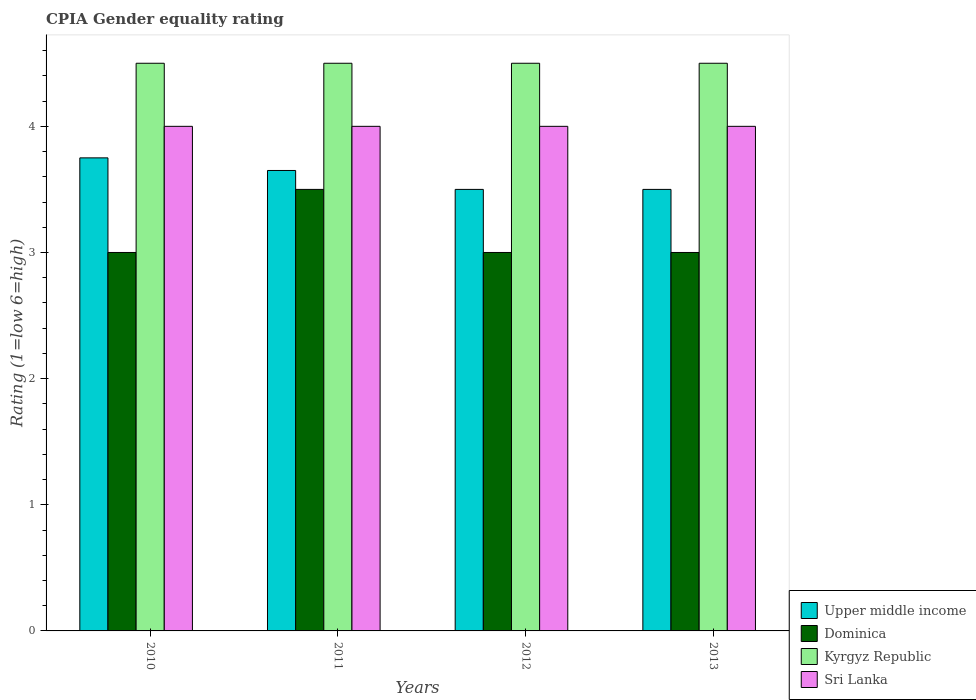How many different coloured bars are there?
Your response must be concise. 4. Are the number of bars per tick equal to the number of legend labels?
Offer a very short reply. Yes. How many bars are there on the 4th tick from the left?
Make the answer very short. 4. In how many cases, is the number of bars for a given year not equal to the number of legend labels?
Make the answer very short. 0. What is the CPIA rating in Upper middle income in 2013?
Provide a short and direct response. 3.5. Across all years, what is the maximum CPIA rating in Upper middle income?
Keep it short and to the point. 3.75. In which year was the CPIA rating in Kyrgyz Republic maximum?
Keep it short and to the point. 2010. What is the total CPIA rating in Sri Lanka in the graph?
Give a very brief answer. 16. Is the difference between the CPIA rating in Sri Lanka in 2010 and 2012 greater than the difference between the CPIA rating in Kyrgyz Republic in 2010 and 2012?
Your answer should be compact. No. In how many years, is the CPIA rating in Dominica greater than the average CPIA rating in Dominica taken over all years?
Your response must be concise. 1. What does the 4th bar from the left in 2012 represents?
Give a very brief answer. Sri Lanka. What does the 3rd bar from the right in 2011 represents?
Your response must be concise. Dominica. Is it the case that in every year, the sum of the CPIA rating in Kyrgyz Republic and CPIA rating in Upper middle income is greater than the CPIA rating in Dominica?
Offer a terse response. Yes. How many bars are there?
Ensure brevity in your answer.  16. How many years are there in the graph?
Offer a very short reply. 4. What is the difference between two consecutive major ticks on the Y-axis?
Make the answer very short. 1. Does the graph contain any zero values?
Your response must be concise. No. Where does the legend appear in the graph?
Make the answer very short. Bottom right. How many legend labels are there?
Your answer should be compact. 4. What is the title of the graph?
Offer a terse response. CPIA Gender equality rating. What is the Rating (1=low 6=high) in Upper middle income in 2010?
Provide a succinct answer. 3.75. What is the Rating (1=low 6=high) in Dominica in 2010?
Give a very brief answer. 3. What is the Rating (1=low 6=high) in Upper middle income in 2011?
Provide a short and direct response. 3.65. What is the Rating (1=low 6=high) in Dominica in 2011?
Give a very brief answer. 3.5. What is the Rating (1=low 6=high) of Upper middle income in 2012?
Keep it short and to the point. 3.5. What is the Rating (1=low 6=high) of Kyrgyz Republic in 2012?
Your answer should be compact. 4.5. What is the Rating (1=low 6=high) of Sri Lanka in 2012?
Give a very brief answer. 4. Across all years, what is the maximum Rating (1=low 6=high) of Upper middle income?
Your response must be concise. 3.75. Across all years, what is the maximum Rating (1=low 6=high) in Dominica?
Provide a succinct answer. 3.5. Across all years, what is the minimum Rating (1=low 6=high) of Kyrgyz Republic?
Your answer should be very brief. 4.5. What is the total Rating (1=low 6=high) in Upper middle income in the graph?
Ensure brevity in your answer.  14.4. What is the total Rating (1=low 6=high) in Sri Lanka in the graph?
Provide a succinct answer. 16. What is the difference between the Rating (1=low 6=high) of Upper middle income in 2010 and that in 2011?
Your response must be concise. 0.1. What is the difference between the Rating (1=low 6=high) in Sri Lanka in 2010 and that in 2011?
Your answer should be compact. 0. What is the difference between the Rating (1=low 6=high) of Upper middle income in 2010 and that in 2012?
Your answer should be very brief. 0.25. What is the difference between the Rating (1=low 6=high) in Kyrgyz Republic in 2010 and that in 2012?
Your response must be concise. 0. What is the difference between the Rating (1=low 6=high) of Sri Lanka in 2010 and that in 2012?
Your answer should be very brief. 0. What is the difference between the Rating (1=low 6=high) of Kyrgyz Republic in 2010 and that in 2013?
Offer a terse response. 0. What is the difference between the Rating (1=low 6=high) of Sri Lanka in 2011 and that in 2012?
Provide a succinct answer. 0. What is the difference between the Rating (1=low 6=high) of Upper middle income in 2011 and that in 2013?
Your answer should be compact. 0.15. What is the difference between the Rating (1=low 6=high) in Dominica in 2011 and that in 2013?
Provide a short and direct response. 0.5. What is the difference between the Rating (1=low 6=high) of Kyrgyz Republic in 2011 and that in 2013?
Give a very brief answer. 0. What is the difference between the Rating (1=low 6=high) of Sri Lanka in 2011 and that in 2013?
Your answer should be very brief. 0. What is the difference between the Rating (1=low 6=high) in Dominica in 2012 and that in 2013?
Your response must be concise. 0. What is the difference between the Rating (1=low 6=high) in Sri Lanka in 2012 and that in 2013?
Your answer should be compact. 0. What is the difference between the Rating (1=low 6=high) in Upper middle income in 2010 and the Rating (1=low 6=high) in Dominica in 2011?
Your response must be concise. 0.25. What is the difference between the Rating (1=low 6=high) in Upper middle income in 2010 and the Rating (1=low 6=high) in Kyrgyz Republic in 2011?
Offer a very short reply. -0.75. What is the difference between the Rating (1=low 6=high) of Dominica in 2010 and the Rating (1=low 6=high) of Kyrgyz Republic in 2011?
Offer a terse response. -1.5. What is the difference between the Rating (1=low 6=high) of Upper middle income in 2010 and the Rating (1=low 6=high) of Dominica in 2012?
Your answer should be very brief. 0.75. What is the difference between the Rating (1=low 6=high) of Upper middle income in 2010 and the Rating (1=low 6=high) of Kyrgyz Republic in 2012?
Provide a succinct answer. -0.75. What is the difference between the Rating (1=low 6=high) in Dominica in 2010 and the Rating (1=low 6=high) in Kyrgyz Republic in 2012?
Ensure brevity in your answer.  -1.5. What is the difference between the Rating (1=low 6=high) in Upper middle income in 2010 and the Rating (1=low 6=high) in Dominica in 2013?
Give a very brief answer. 0.75. What is the difference between the Rating (1=low 6=high) in Upper middle income in 2010 and the Rating (1=low 6=high) in Kyrgyz Republic in 2013?
Ensure brevity in your answer.  -0.75. What is the difference between the Rating (1=low 6=high) of Upper middle income in 2010 and the Rating (1=low 6=high) of Sri Lanka in 2013?
Make the answer very short. -0.25. What is the difference between the Rating (1=low 6=high) in Dominica in 2010 and the Rating (1=low 6=high) in Kyrgyz Republic in 2013?
Offer a terse response. -1.5. What is the difference between the Rating (1=low 6=high) in Dominica in 2010 and the Rating (1=low 6=high) in Sri Lanka in 2013?
Ensure brevity in your answer.  -1. What is the difference between the Rating (1=low 6=high) in Upper middle income in 2011 and the Rating (1=low 6=high) in Dominica in 2012?
Offer a terse response. 0.65. What is the difference between the Rating (1=low 6=high) in Upper middle income in 2011 and the Rating (1=low 6=high) in Kyrgyz Republic in 2012?
Make the answer very short. -0.85. What is the difference between the Rating (1=low 6=high) in Upper middle income in 2011 and the Rating (1=low 6=high) in Sri Lanka in 2012?
Ensure brevity in your answer.  -0.35. What is the difference between the Rating (1=low 6=high) in Kyrgyz Republic in 2011 and the Rating (1=low 6=high) in Sri Lanka in 2012?
Give a very brief answer. 0.5. What is the difference between the Rating (1=low 6=high) of Upper middle income in 2011 and the Rating (1=low 6=high) of Dominica in 2013?
Your answer should be compact. 0.65. What is the difference between the Rating (1=low 6=high) in Upper middle income in 2011 and the Rating (1=low 6=high) in Kyrgyz Republic in 2013?
Your response must be concise. -0.85. What is the difference between the Rating (1=low 6=high) of Upper middle income in 2011 and the Rating (1=low 6=high) of Sri Lanka in 2013?
Offer a terse response. -0.35. What is the difference between the Rating (1=low 6=high) of Dominica in 2011 and the Rating (1=low 6=high) of Kyrgyz Republic in 2013?
Make the answer very short. -1. What is the difference between the Rating (1=low 6=high) in Kyrgyz Republic in 2011 and the Rating (1=low 6=high) in Sri Lanka in 2013?
Your answer should be very brief. 0.5. What is the difference between the Rating (1=low 6=high) in Dominica in 2012 and the Rating (1=low 6=high) in Sri Lanka in 2013?
Your answer should be compact. -1. What is the difference between the Rating (1=low 6=high) in Kyrgyz Republic in 2012 and the Rating (1=low 6=high) in Sri Lanka in 2013?
Offer a terse response. 0.5. What is the average Rating (1=low 6=high) of Dominica per year?
Offer a very short reply. 3.12. What is the average Rating (1=low 6=high) of Sri Lanka per year?
Make the answer very short. 4. In the year 2010, what is the difference between the Rating (1=low 6=high) in Upper middle income and Rating (1=low 6=high) in Dominica?
Offer a very short reply. 0.75. In the year 2010, what is the difference between the Rating (1=low 6=high) in Upper middle income and Rating (1=low 6=high) in Kyrgyz Republic?
Make the answer very short. -0.75. In the year 2010, what is the difference between the Rating (1=low 6=high) of Dominica and Rating (1=low 6=high) of Sri Lanka?
Provide a short and direct response. -1. In the year 2011, what is the difference between the Rating (1=low 6=high) of Upper middle income and Rating (1=low 6=high) of Kyrgyz Republic?
Keep it short and to the point. -0.85. In the year 2011, what is the difference between the Rating (1=low 6=high) in Upper middle income and Rating (1=low 6=high) in Sri Lanka?
Provide a succinct answer. -0.35. In the year 2011, what is the difference between the Rating (1=low 6=high) of Dominica and Rating (1=low 6=high) of Kyrgyz Republic?
Offer a terse response. -1. In the year 2011, what is the difference between the Rating (1=low 6=high) in Dominica and Rating (1=low 6=high) in Sri Lanka?
Offer a terse response. -0.5. In the year 2011, what is the difference between the Rating (1=low 6=high) of Kyrgyz Republic and Rating (1=low 6=high) of Sri Lanka?
Keep it short and to the point. 0.5. In the year 2012, what is the difference between the Rating (1=low 6=high) of Upper middle income and Rating (1=low 6=high) of Kyrgyz Republic?
Ensure brevity in your answer.  -1. In the year 2012, what is the difference between the Rating (1=low 6=high) in Upper middle income and Rating (1=low 6=high) in Sri Lanka?
Provide a succinct answer. -0.5. In the year 2012, what is the difference between the Rating (1=low 6=high) in Dominica and Rating (1=low 6=high) in Kyrgyz Republic?
Offer a terse response. -1.5. In the year 2012, what is the difference between the Rating (1=low 6=high) of Kyrgyz Republic and Rating (1=low 6=high) of Sri Lanka?
Offer a terse response. 0.5. In the year 2013, what is the difference between the Rating (1=low 6=high) in Upper middle income and Rating (1=low 6=high) in Dominica?
Make the answer very short. 0.5. In the year 2013, what is the difference between the Rating (1=low 6=high) of Upper middle income and Rating (1=low 6=high) of Sri Lanka?
Keep it short and to the point. -0.5. In the year 2013, what is the difference between the Rating (1=low 6=high) in Dominica and Rating (1=low 6=high) in Sri Lanka?
Give a very brief answer. -1. What is the ratio of the Rating (1=low 6=high) of Upper middle income in 2010 to that in 2011?
Provide a succinct answer. 1.03. What is the ratio of the Rating (1=low 6=high) of Dominica in 2010 to that in 2011?
Give a very brief answer. 0.86. What is the ratio of the Rating (1=low 6=high) of Upper middle income in 2010 to that in 2012?
Your answer should be very brief. 1.07. What is the ratio of the Rating (1=low 6=high) of Kyrgyz Republic in 2010 to that in 2012?
Provide a short and direct response. 1. What is the ratio of the Rating (1=low 6=high) of Sri Lanka in 2010 to that in 2012?
Your response must be concise. 1. What is the ratio of the Rating (1=low 6=high) of Upper middle income in 2010 to that in 2013?
Ensure brevity in your answer.  1.07. What is the ratio of the Rating (1=low 6=high) in Sri Lanka in 2010 to that in 2013?
Offer a terse response. 1. What is the ratio of the Rating (1=low 6=high) in Upper middle income in 2011 to that in 2012?
Offer a terse response. 1.04. What is the ratio of the Rating (1=low 6=high) of Kyrgyz Republic in 2011 to that in 2012?
Offer a very short reply. 1. What is the ratio of the Rating (1=low 6=high) of Upper middle income in 2011 to that in 2013?
Ensure brevity in your answer.  1.04. What is the ratio of the Rating (1=low 6=high) in Kyrgyz Republic in 2011 to that in 2013?
Offer a very short reply. 1. What is the ratio of the Rating (1=low 6=high) of Sri Lanka in 2011 to that in 2013?
Ensure brevity in your answer.  1. What is the ratio of the Rating (1=low 6=high) in Upper middle income in 2012 to that in 2013?
Your answer should be very brief. 1. What is the ratio of the Rating (1=low 6=high) of Dominica in 2012 to that in 2013?
Your answer should be compact. 1. What is the ratio of the Rating (1=low 6=high) in Sri Lanka in 2012 to that in 2013?
Provide a short and direct response. 1. What is the difference between the highest and the second highest Rating (1=low 6=high) of Dominica?
Give a very brief answer. 0.5. What is the difference between the highest and the second highest Rating (1=low 6=high) of Sri Lanka?
Offer a terse response. 0. What is the difference between the highest and the lowest Rating (1=low 6=high) in Kyrgyz Republic?
Your response must be concise. 0. 